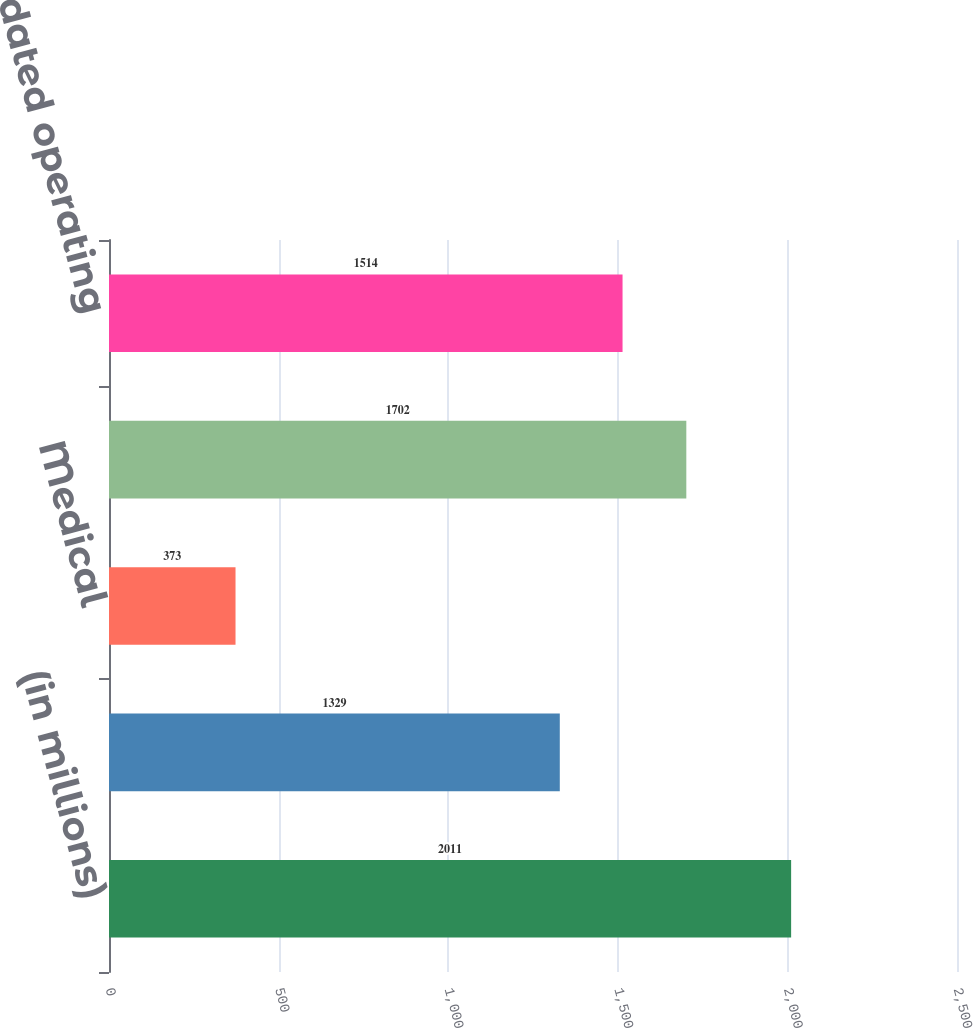<chart> <loc_0><loc_0><loc_500><loc_500><bar_chart><fcel>(in millions)<fcel>Pharmaceutical<fcel>Medical<fcel>Total segment profit<fcel>Total consolidated operating<nl><fcel>2011<fcel>1329<fcel>373<fcel>1702<fcel>1514<nl></chart> 